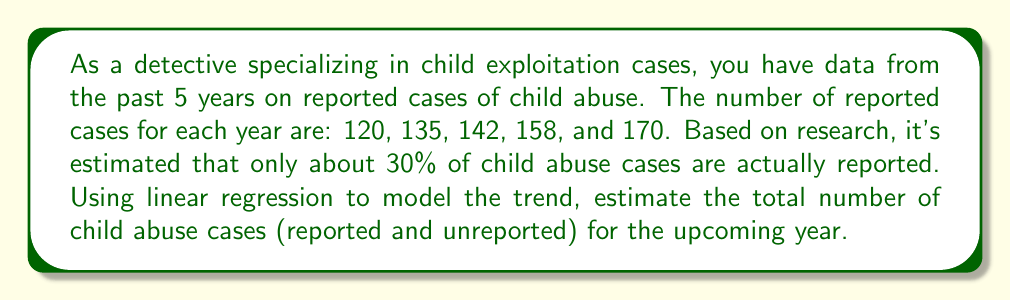Show me your answer to this math problem. To solve this problem, we'll follow these steps:

1) First, let's set up our data points:
   Year (x): 1, 2, 3, 4, 5
   Reported cases (y): 120, 135, 142, 158, 170

2) We'll use the linear regression formula to find the slope (m) and y-intercept (b):
   
   $$m = \frac{n\sum xy - \sum x \sum y}{n\sum x^2 - (\sum x)^2}$$
   
   $$b = \bar{y} - m\bar{x}$$

3) Calculate the sums:
   $\sum x = 15$, $\sum y = 725$, $\sum xy = 2,315$, $\sum x^2 = 55$
   $n = 5$

4) Plug into the slope formula:
   
   $$m = \frac{5(2,315) - 15(725)}{5(55) - 15^2} = \frac{11,575 - 10,875}{275 - 225} = \frac{700}{50} = 14$$

5) Calculate averages:
   $\bar{x} = 3$, $\bar{y} = 145$

6) Find the y-intercept:
   
   $$b = 145 - 14(3) = 103$$

7) Our linear regression equation is:
   
   $$y = 14x + 103$$

8) To predict the next year (year 6):
   
   $$y = 14(6) + 103 = 187$$

9) This predicts 187 reported cases for year 6. However, this only represents 30% of total cases.

10) To find the total number of cases:
    
    $$\text{Total cases} = \frac{\text{Reported cases}}{0.30} = \frac{187}{0.30} = 623.33$$
Answer: The estimated total number of child abuse cases (reported and unreported) for the upcoming year is approximately 623. 